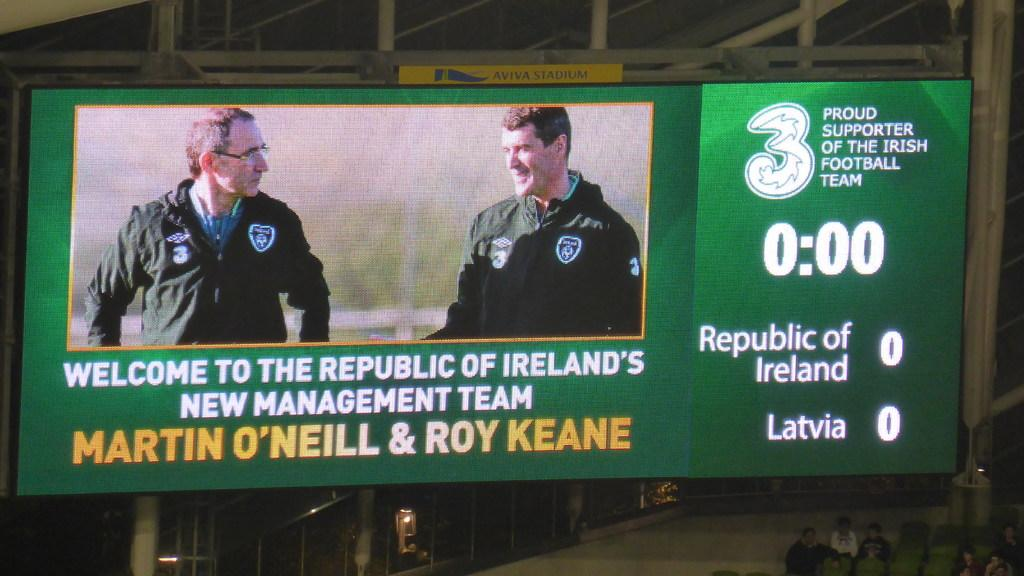<image>
Summarize the visual content of the image. Green screen that says Marti O'Neill as well as Roy Keane. 